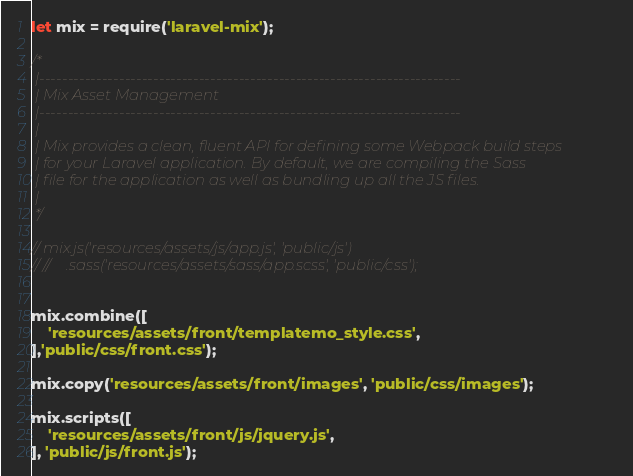Convert code to text. <code><loc_0><loc_0><loc_500><loc_500><_JavaScript_>let mix = require('laravel-mix');

/*
 |--------------------------------------------------------------------------
 | Mix Asset Management
 |--------------------------------------------------------------------------
 |
 | Mix provides a clean, fluent API for defining some Webpack build steps
 | for your Laravel application. By default, we are compiling the Sass
 | file for the application as well as bundling up all the JS files.
 |
 */

// mix.js('resources/assets/js/app.js', 'public/js')
// //    .sass('resources/assets/sass/app.scss', 'public/css');


mix.combine([
    'resources/assets/front/templatemo_style.css',
],'public/css/front.css');

mix.copy('resources/assets/front/images', 'public/css/images');

mix.scripts([
    'resources/assets/front/js/jquery.js',
], 'public/js/front.js');</code> 